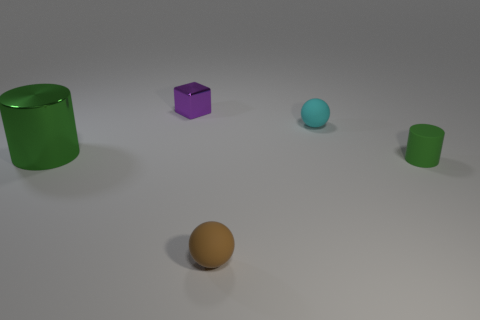What size is the cyan object?
Keep it short and to the point. Small. Is the rubber cylinder the same size as the green shiny thing?
Offer a very short reply. No. How many objects are tiny rubber things left of the small green rubber object or green cylinders to the left of the brown matte thing?
Your response must be concise. 3. There is a small rubber ball that is behind the green cylinder behind the tiny cylinder; what number of rubber things are left of it?
Offer a very short reply. 1. There is a shiny thing behind the large object; what size is it?
Keep it short and to the point. Small. What number of green matte objects are the same size as the purple thing?
Your response must be concise. 1. Is the size of the green metal thing the same as the thing on the right side of the cyan ball?
Your answer should be compact. No. What number of objects are small blue blocks or purple objects?
Keep it short and to the point. 1. What number of tiny metallic blocks have the same color as the large cylinder?
Your response must be concise. 0. There is a cyan thing that is the same size as the block; what shape is it?
Ensure brevity in your answer.  Sphere. 